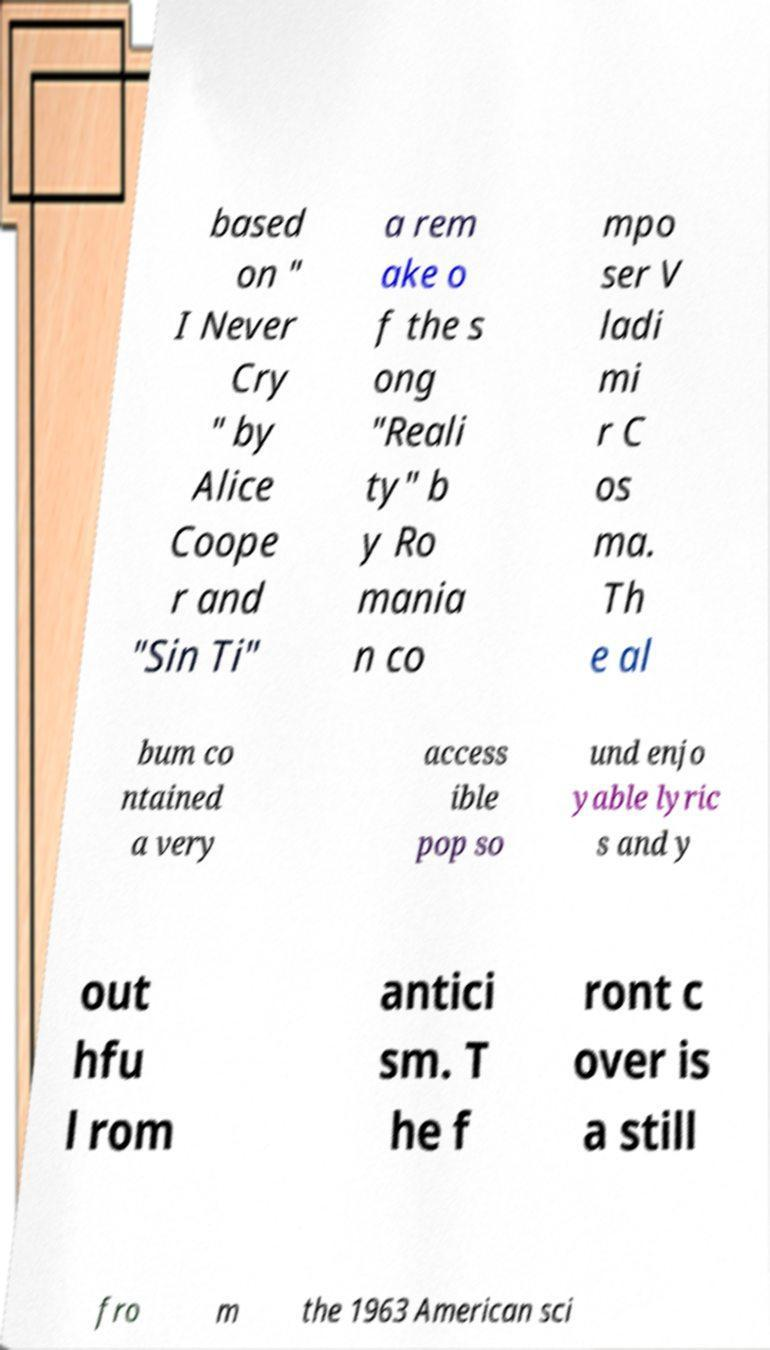Could you assist in decoding the text presented in this image and type it out clearly? based on " I Never Cry " by Alice Coope r and "Sin Ti" a rem ake o f the s ong "Reali ty" b y Ro mania n co mpo ser V ladi mi r C os ma. Th e al bum co ntained a very access ible pop so und enjo yable lyric s and y out hfu l rom antici sm. T he f ront c over is a still fro m the 1963 American sci 